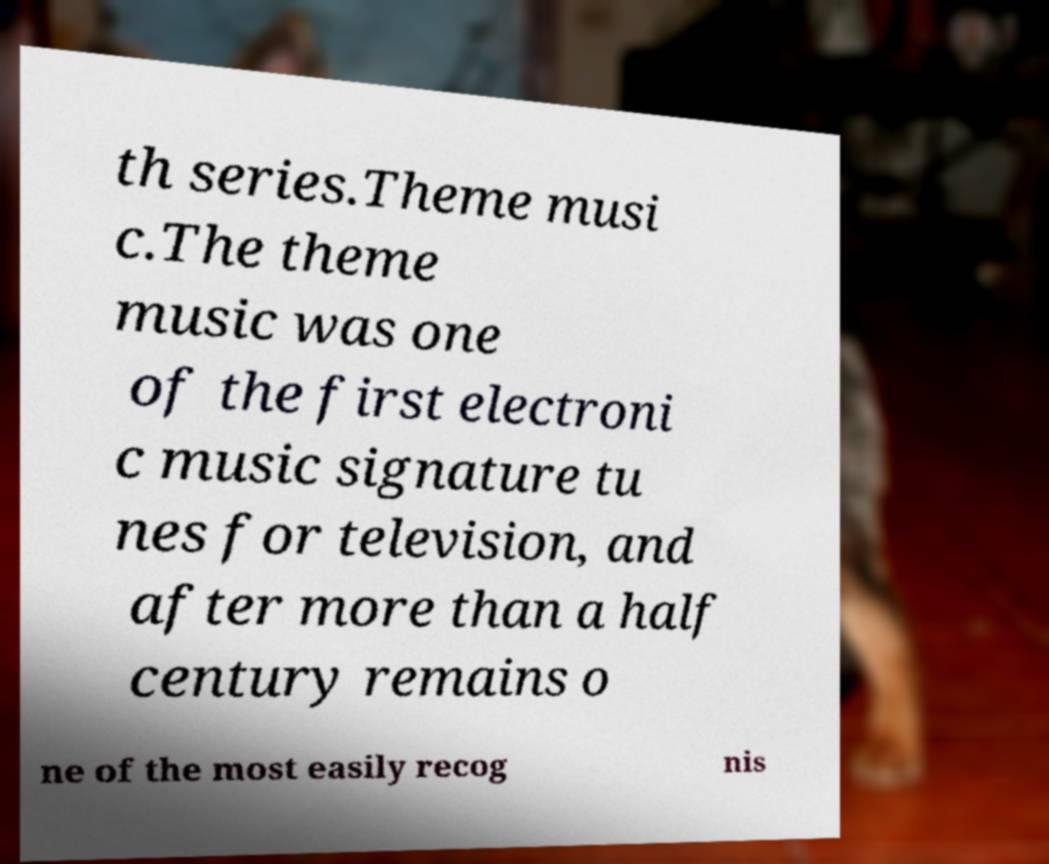I need the written content from this picture converted into text. Can you do that? th series.Theme musi c.The theme music was one of the first electroni c music signature tu nes for television, and after more than a half century remains o ne of the most easily recog nis 